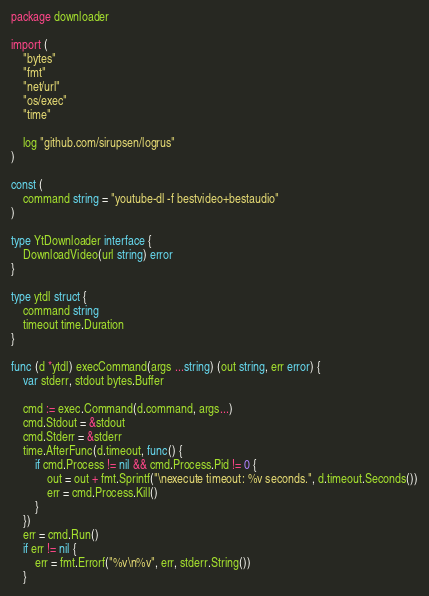<code> <loc_0><loc_0><loc_500><loc_500><_Go_>package downloader

import (
	"bytes"
	"fmt"
	"net/url"
	"os/exec"
	"time"

	log "github.com/sirupsen/logrus"
)

const (
	command string = "youtube-dl -f bestvideo+bestaudio"
)

type YtDownloader interface {
	DownloadVideo(url string) error
}

type ytdl struct {
	command string
	timeout time.Duration
}

func (d *ytdl) execCommand(args ...string) (out string, err error) {
	var stderr, stdout bytes.Buffer

	cmd := exec.Command(d.command, args...)
	cmd.Stdout = &stdout
	cmd.Stderr = &stderr
	time.AfterFunc(d.timeout, func() {
		if cmd.Process != nil && cmd.Process.Pid != 0 {
			out = out + fmt.Sprintf("\nexecute timeout: %v seconds.", d.timeout.Seconds())
			err = cmd.Process.Kill()
		}
	})
	err = cmd.Run()
	if err != nil {
		err = fmt.Errorf("%v\n%v", err, stderr.String())
	}</code> 